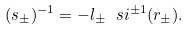Convert formula to latex. <formula><loc_0><loc_0><loc_500><loc_500>( s _ { \pm } ) ^ { - 1 } = - l _ { \pm } \ s i ^ { \pm 1 } ( r _ { \pm } ) .</formula> 